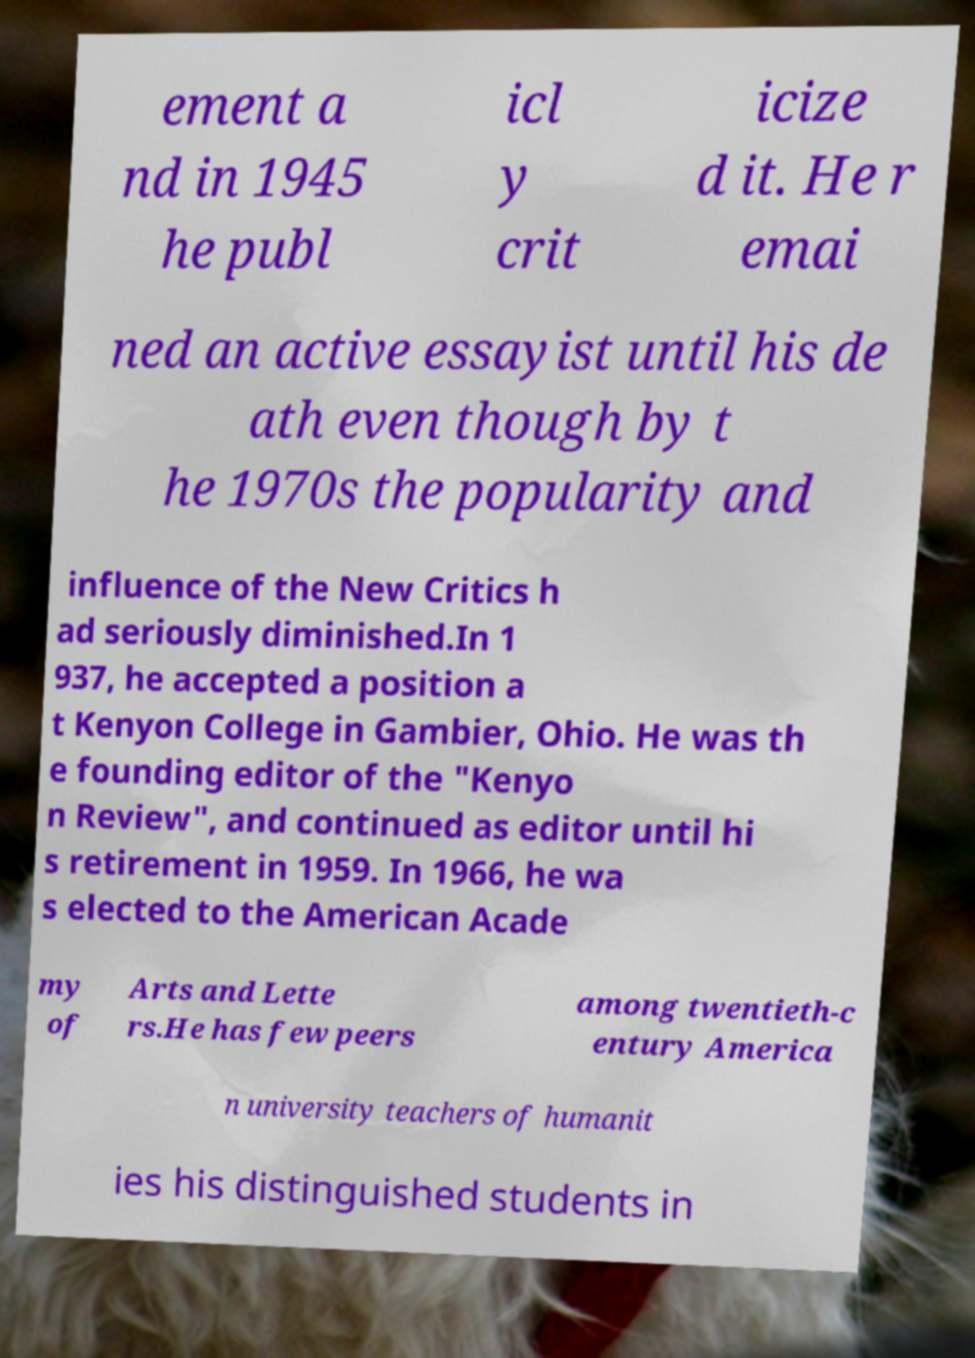Please read and relay the text visible in this image. What does it say? ement a nd in 1945 he publ icl y crit icize d it. He r emai ned an active essayist until his de ath even though by t he 1970s the popularity and influence of the New Critics h ad seriously diminished.In 1 937, he accepted a position a t Kenyon College in Gambier, Ohio. He was th e founding editor of the "Kenyo n Review", and continued as editor until hi s retirement in 1959. In 1966, he wa s elected to the American Acade my of Arts and Lette rs.He has few peers among twentieth-c entury America n university teachers of humanit ies his distinguished students in 